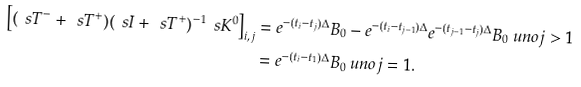Convert formula to latex. <formula><loc_0><loc_0><loc_500><loc_500>\left [ ( \ s T ^ { - } + \ s T ^ { + } ) ( \ s I + \ s T ^ { + } ) ^ { - 1 } \ s K ^ { 0 } \right ] _ { i , j } & = e ^ { - ( t _ { i } - t _ { j } ) \Delta } B _ { 0 } - e ^ { - ( t _ { i } - t _ { j - 1 } ) \Delta } e ^ { - ( t _ { j - 1 } - t _ { j } ) \Delta } B _ { 0 } \ u n o { j > 1 } \\ & = e ^ { - ( t _ { i } - t _ { 1 } ) \Delta } B _ { 0 } \ u n o { j = 1 } .</formula> 